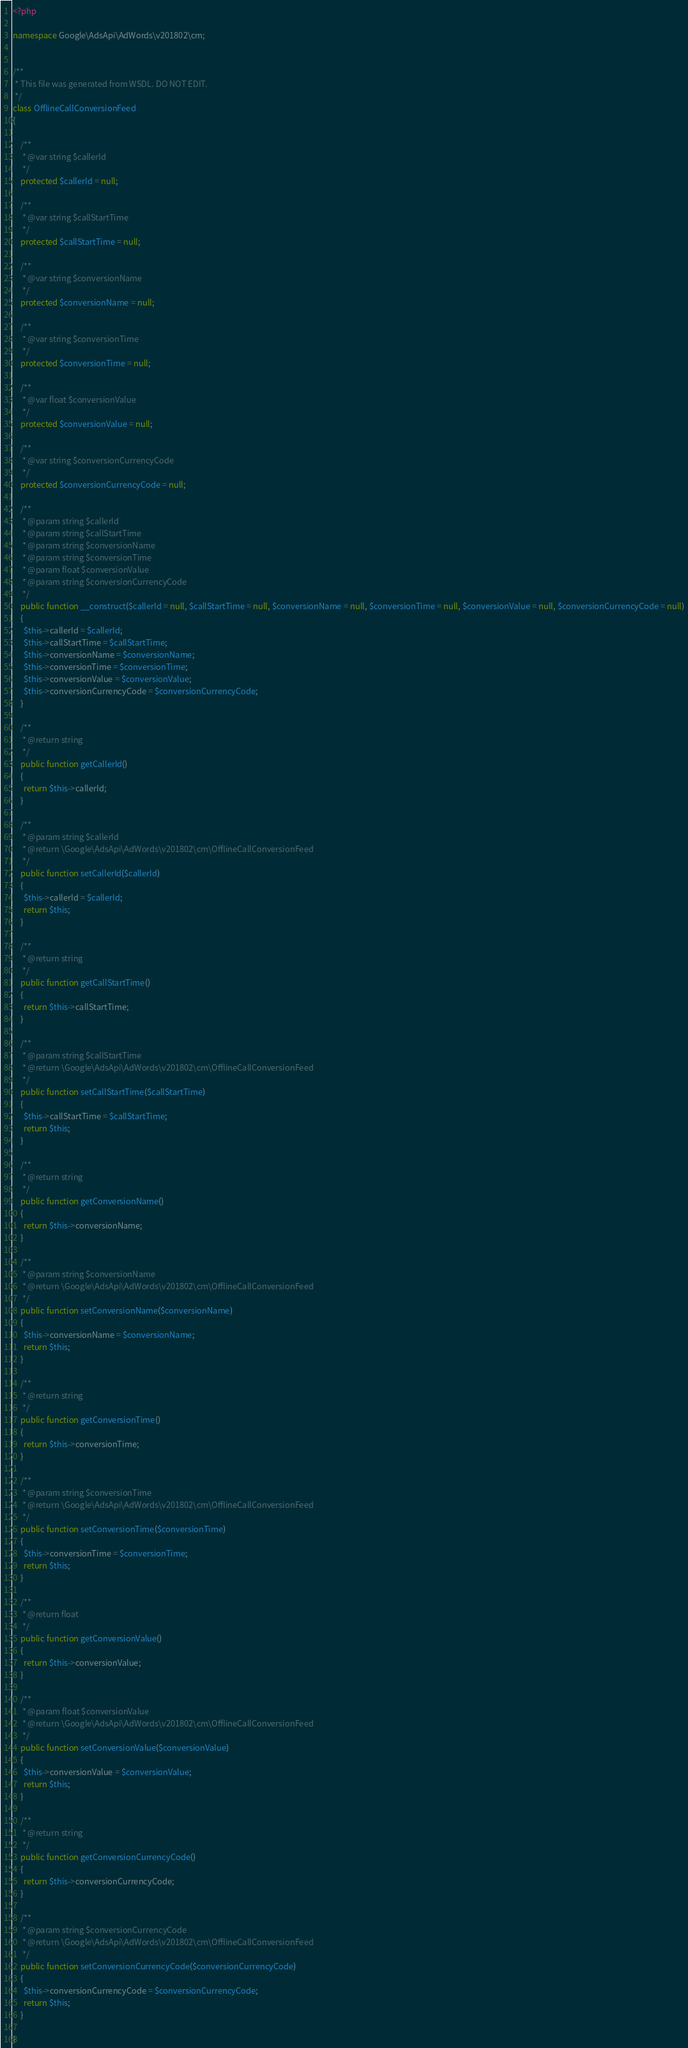<code> <loc_0><loc_0><loc_500><loc_500><_PHP_><?php

namespace Google\AdsApi\AdWords\v201802\cm;


/**
 * This file was generated from WSDL. DO NOT EDIT.
 */
class OfflineCallConversionFeed
{

    /**
     * @var string $callerId
     */
    protected $callerId = null;

    /**
     * @var string $callStartTime
     */
    protected $callStartTime = null;

    /**
     * @var string $conversionName
     */
    protected $conversionName = null;

    /**
     * @var string $conversionTime
     */
    protected $conversionTime = null;

    /**
     * @var float $conversionValue
     */
    protected $conversionValue = null;

    /**
     * @var string $conversionCurrencyCode
     */
    protected $conversionCurrencyCode = null;

    /**
     * @param string $callerId
     * @param string $callStartTime
     * @param string $conversionName
     * @param string $conversionTime
     * @param float $conversionValue
     * @param string $conversionCurrencyCode
     */
    public function __construct($callerId = null, $callStartTime = null, $conversionName = null, $conversionTime = null, $conversionValue = null, $conversionCurrencyCode = null)
    {
      $this->callerId = $callerId;
      $this->callStartTime = $callStartTime;
      $this->conversionName = $conversionName;
      $this->conversionTime = $conversionTime;
      $this->conversionValue = $conversionValue;
      $this->conversionCurrencyCode = $conversionCurrencyCode;
    }

    /**
     * @return string
     */
    public function getCallerId()
    {
      return $this->callerId;
    }

    /**
     * @param string $callerId
     * @return \Google\AdsApi\AdWords\v201802\cm\OfflineCallConversionFeed
     */
    public function setCallerId($callerId)
    {
      $this->callerId = $callerId;
      return $this;
    }

    /**
     * @return string
     */
    public function getCallStartTime()
    {
      return $this->callStartTime;
    }

    /**
     * @param string $callStartTime
     * @return \Google\AdsApi\AdWords\v201802\cm\OfflineCallConversionFeed
     */
    public function setCallStartTime($callStartTime)
    {
      $this->callStartTime = $callStartTime;
      return $this;
    }

    /**
     * @return string
     */
    public function getConversionName()
    {
      return $this->conversionName;
    }

    /**
     * @param string $conversionName
     * @return \Google\AdsApi\AdWords\v201802\cm\OfflineCallConversionFeed
     */
    public function setConversionName($conversionName)
    {
      $this->conversionName = $conversionName;
      return $this;
    }

    /**
     * @return string
     */
    public function getConversionTime()
    {
      return $this->conversionTime;
    }

    /**
     * @param string $conversionTime
     * @return \Google\AdsApi\AdWords\v201802\cm\OfflineCallConversionFeed
     */
    public function setConversionTime($conversionTime)
    {
      $this->conversionTime = $conversionTime;
      return $this;
    }

    /**
     * @return float
     */
    public function getConversionValue()
    {
      return $this->conversionValue;
    }

    /**
     * @param float $conversionValue
     * @return \Google\AdsApi\AdWords\v201802\cm\OfflineCallConversionFeed
     */
    public function setConversionValue($conversionValue)
    {
      $this->conversionValue = $conversionValue;
      return $this;
    }

    /**
     * @return string
     */
    public function getConversionCurrencyCode()
    {
      return $this->conversionCurrencyCode;
    }

    /**
     * @param string $conversionCurrencyCode
     * @return \Google\AdsApi\AdWords\v201802\cm\OfflineCallConversionFeed
     */
    public function setConversionCurrencyCode($conversionCurrencyCode)
    {
      $this->conversionCurrencyCode = $conversionCurrencyCode;
      return $this;
    }

}
</code> 